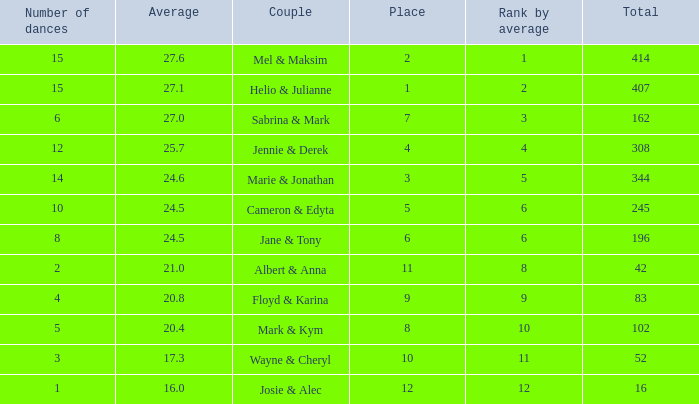What is the average when the rank by average is more than 12? None. 